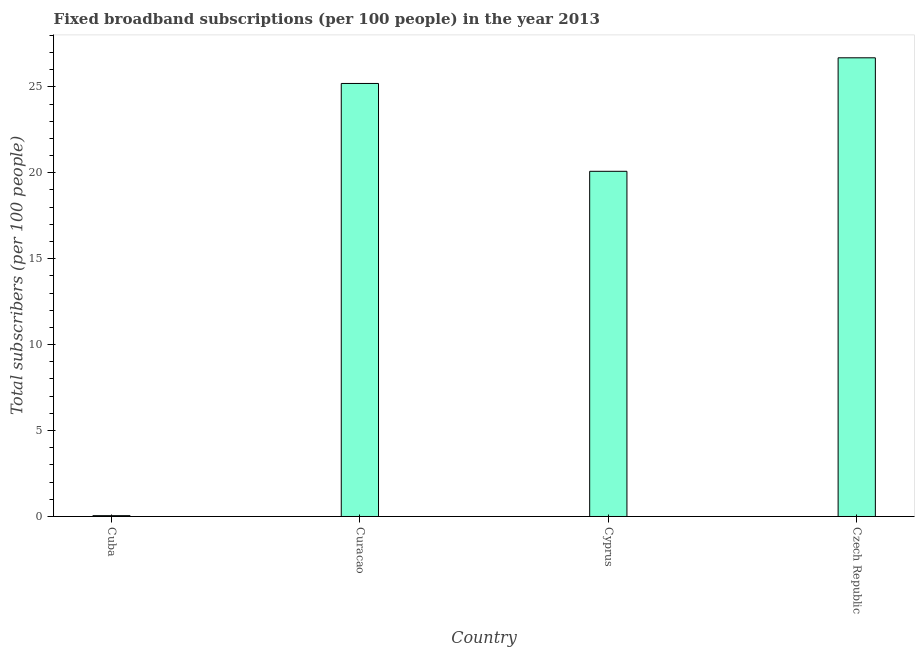Does the graph contain any zero values?
Provide a succinct answer. No. What is the title of the graph?
Offer a very short reply. Fixed broadband subscriptions (per 100 people) in the year 2013. What is the label or title of the Y-axis?
Keep it short and to the point. Total subscribers (per 100 people). What is the total number of fixed broadband subscriptions in Cyprus?
Your answer should be very brief. 20.08. Across all countries, what is the maximum total number of fixed broadband subscriptions?
Keep it short and to the point. 26.69. Across all countries, what is the minimum total number of fixed broadband subscriptions?
Keep it short and to the point. 0.05. In which country was the total number of fixed broadband subscriptions maximum?
Give a very brief answer. Czech Republic. In which country was the total number of fixed broadband subscriptions minimum?
Ensure brevity in your answer.  Cuba. What is the sum of the total number of fixed broadband subscriptions?
Make the answer very short. 72.01. What is the difference between the total number of fixed broadband subscriptions in Curacao and Czech Republic?
Keep it short and to the point. -1.49. What is the average total number of fixed broadband subscriptions per country?
Offer a terse response. 18. What is the median total number of fixed broadband subscriptions?
Keep it short and to the point. 22.64. In how many countries, is the total number of fixed broadband subscriptions greater than 15 ?
Your answer should be compact. 3. What is the ratio of the total number of fixed broadband subscriptions in Cyprus to that in Czech Republic?
Provide a succinct answer. 0.75. Is the difference between the total number of fixed broadband subscriptions in Curacao and Czech Republic greater than the difference between any two countries?
Provide a succinct answer. No. What is the difference between the highest and the second highest total number of fixed broadband subscriptions?
Keep it short and to the point. 1.49. Is the sum of the total number of fixed broadband subscriptions in Cuba and Cyprus greater than the maximum total number of fixed broadband subscriptions across all countries?
Your answer should be very brief. No. What is the difference between the highest and the lowest total number of fixed broadband subscriptions?
Ensure brevity in your answer.  26.64. Are all the bars in the graph horizontal?
Keep it short and to the point. No. How many countries are there in the graph?
Offer a terse response. 4. What is the Total subscribers (per 100 people) of Cuba?
Your response must be concise. 0.05. What is the Total subscribers (per 100 people) in Curacao?
Make the answer very short. 25.2. What is the Total subscribers (per 100 people) in Cyprus?
Provide a short and direct response. 20.08. What is the Total subscribers (per 100 people) in Czech Republic?
Keep it short and to the point. 26.69. What is the difference between the Total subscribers (per 100 people) in Cuba and Curacao?
Offer a very short reply. -25.15. What is the difference between the Total subscribers (per 100 people) in Cuba and Cyprus?
Provide a succinct answer. -20.04. What is the difference between the Total subscribers (per 100 people) in Cuba and Czech Republic?
Keep it short and to the point. -26.64. What is the difference between the Total subscribers (per 100 people) in Curacao and Cyprus?
Offer a terse response. 5.11. What is the difference between the Total subscribers (per 100 people) in Curacao and Czech Republic?
Make the answer very short. -1.49. What is the difference between the Total subscribers (per 100 people) in Cyprus and Czech Republic?
Your response must be concise. -6.6. What is the ratio of the Total subscribers (per 100 people) in Cuba to that in Curacao?
Your response must be concise. 0. What is the ratio of the Total subscribers (per 100 people) in Cuba to that in Cyprus?
Offer a terse response. 0. What is the ratio of the Total subscribers (per 100 people) in Cuba to that in Czech Republic?
Provide a succinct answer. 0. What is the ratio of the Total subscribers (per 100 people) in Curacao to that in Cyprus?
Your answer should be compact. 1.25. What is the ratio of the Total subscribers (per 100 people) in Curacao to that in Czech Republic?
Your response must be concise. 0.94. What is the ratio of the Total subscribers (per 100 people) in Cyprus to that in Czech Republic?
Provide a short and direct response. 0.75. 